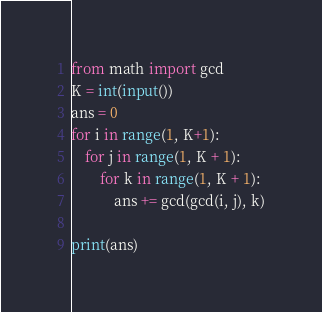<code> <loc_0><loc_0><loc_500><loc_500><_Python_>from math import gcd
K = int(input())
ans = 0
for i in range(1, K+1):
    for j in range(1, K + 1):
        for k in range(1, K + 1):
            ans += gcd(gcd(i, j), k)

print(ans)</code> 